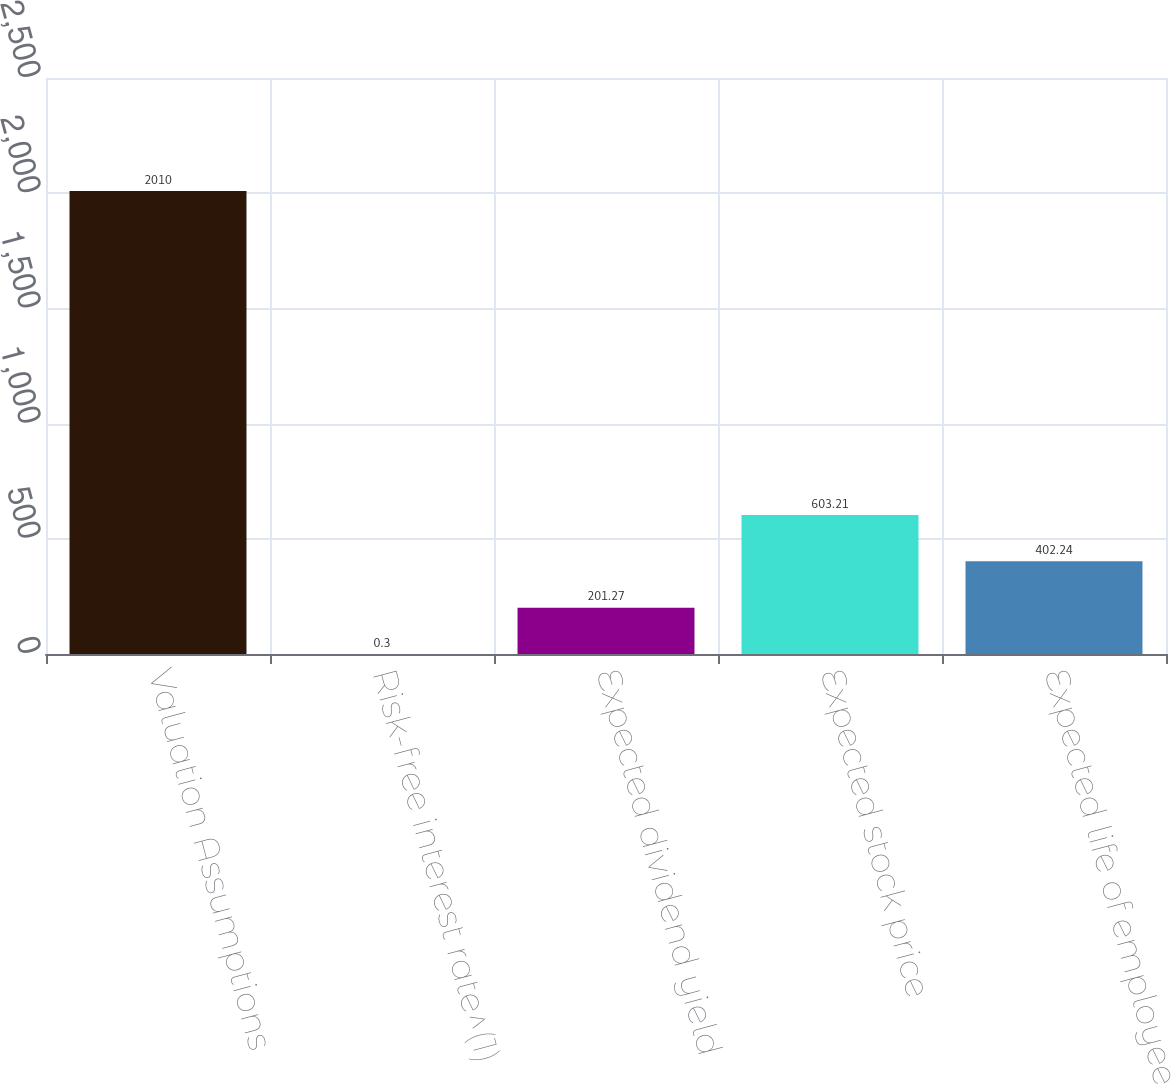<chart> <loc_0><loc_0><loc_500><loc_500><bar_chart><fcel>Valuation Assumptions<fcel>Risk-free interest rate^(1)<fcel>Expected dividend yield<fcel>Expected stock price<fcel>Expected life of employee<nl><fcel>2010<fcel>0.3<fcel>201.27<fcel>603.21<fcel>402.24<nl></chart> 